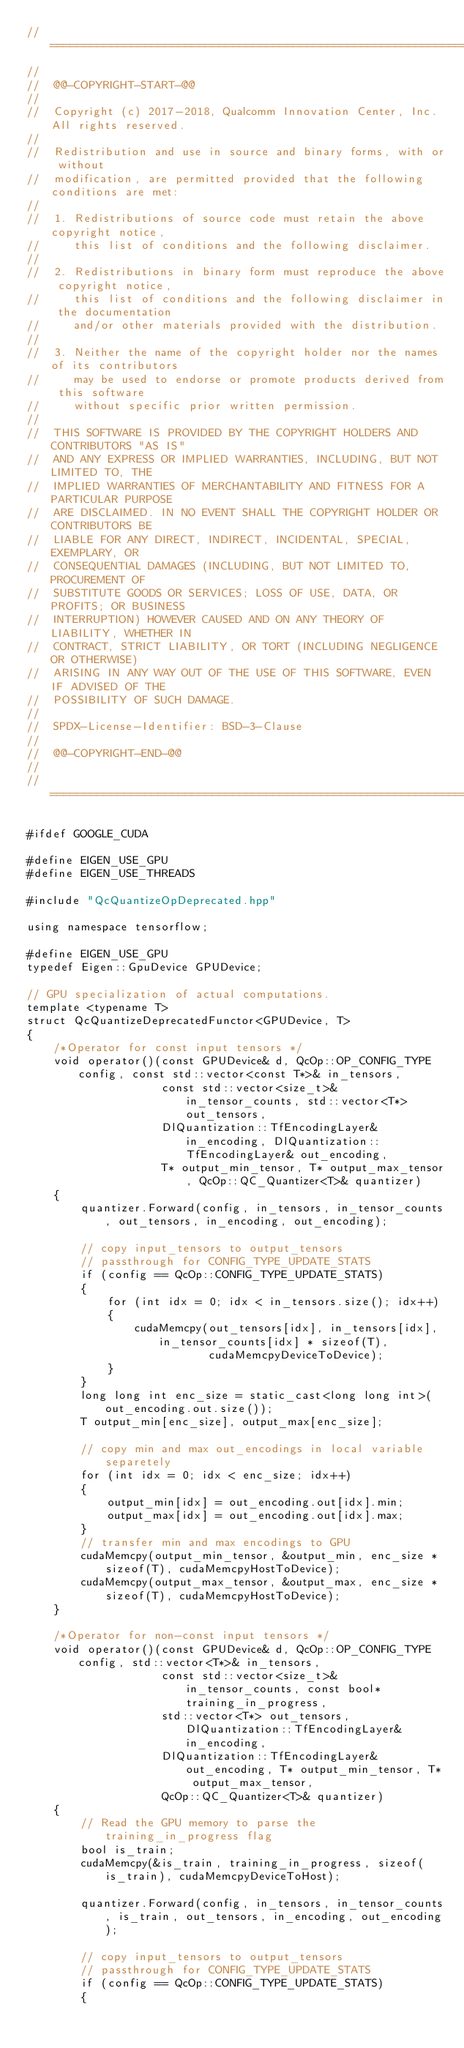Convert code to text. <code><loc_0><loc_0><loc_500><loc_500><_Cuda_>//==============================================================================
//
//  @@-COPYRIGHT-START-@@
//
//  Copyright (c) 2017-2018, Qualcomm Innovation Center, Inc. All rights reserved.
//
//  Redistribution and use in source and binary forms, with or without
//  modification, are permitted provided that the following conditions are met:
//
//  1. Redistributions of source code must retain the above copyright notice,
//     this list of conditions and the following disclaimer.
//
//  2. Redistributions in binary form must reproduce the above copyright notice,
//     this list of conditions and the following disclaimer in the documentation
//     and/or other materials provided with the distribution.
//
//  3. Neither the name of the copyright holder nor the names of its contributors
//     may be used to endorse or promote products derived from this software
//     without specific prior written permission.
//
//  THIS SOFTWARE IS PROVIDED BY THE COPYRIGHT HOLDERS AND CONTRIBUTORS "AS IS"
//  AND ANY EXPRESS OR IMPLIED WARRANTIES, INCLUDING, BUT NOT LIMITED TO, THE
//  IMPLIED WARRANTIES OF MERCHANTABILITY AND FITNESS FOR A PARTICULAR PURPOSE
//  ARE DISCLAIMED. IN NO EVENT SHALL THE COPYRIGHT HOLDER OR CONTRIBUTORS BE
//  LIABLE FOR ANY DIRECT, INDIRECT, INCIDENTAL, SPECIAL, EXEMPLARY, OR
//  CONSEQUENTIAL DAMAGES (INCLUDING, BUT NOT LIMITED TO, PROCUREMENT OF
//  SUBSTITUTE GOODS OR SERVICES; LOSS OF USE, DATA, OR PROFITS; OR BUSINESS
//  INTERRUPTION) HOWEVER CAUSED AND ON ANY THEORY OF LIABILITY, WHETHER IN
//  CONTRACT, STRICT LIABILITY, OR TORT (INCLUDING NEGLIGENCE OR OTHERWISE)
//  ARISING IN ANY WAY OUT OF THE USE OF THIS SOFTWARE, EVEN IF ADVISED OF THE
//  POSSIBILITY OF SUCH DAMAGE.
//
//  SPDX-License-Identifier: BSD-3-Clause
//
//  @@-COPYRIGHT-END-@@
//
//==============================================================================

#ifdef GOOGLE_CUDA

#define EIGEN_USE_GPU
#define EIGEN_USE_THREADS

#include "QcQuantizeOpDeprecated.hpp"

using namespace tensorflow;

#define EIGEN_USE_GPU
typedef Eigen::GpuDevice GPUDevice;

// GPU specialization of actual computations.
template <typename T>
struct QcQuantizeDeprecatedFunctor<GPUDevice, T>
{
    /*Operator for const input tensors */
    void operator()(const GPUDevice& d, QcOp::OP_CONFIG_TYPE config, const std::vector<const T*>& in_tensors,
                    const std::vector<size_t>& in_tensor_counts, std::vector<T*> out_tensors,
                    DlQuantization::TfEncodingLayer& in_encoding, DlQuantization::TfEncodingLayer& out_encoding,
                    T* output_min_tensor, T* output_max_tensor, QcOp::QC_Quantizer<T>& quantizer)
    {
        quantizer.Forward(config, in_tensors, in_tensor_counts, out_tensors, in_encoding, out_encoding);

        // copy input_tensors to output_tensors
        // passthrough for CONFIG_TYPE_UPDATE_STATS
        if (config == QcOp::CONFIG_TYPE_UPDATE_STATS)
        {
            for (int idx = 0; idx < in_tensors.size(); idx++)
            {
                cudaMemcpy(out_tensors[idx], in_tensors[idx], in_tensor_counts[idx] * sizeof(T),
                           cudaMemcpyDeviceToDevice);
            }
        }
        long long int enc_size = static_cast<long long int>(out_encoding.out.size());
        T output_min[enc_size], output_max[enc_size];

        // copy min and max out_encodings in local variable separetely
        for (int idx = 0; idx < enc_size; idx++)
        {
            output_min[idx] = out_encoding.out[idx].min;
            output_max[idx] = out_encoding.out[idx].max;
        }
        // transfer min and max encodings to GPU
        cudaMemcpy(output_min_tensor, &output_min, enc_size * sizeof(T), cudaMemcpyHostToDevice);
        cudaMemcpy(output_max_tensor, &output_max, enc_size * sizeof(T), cudaMemcpyHostToDevice);
    }

    /*Operator for non-const input tensors */
    void operator()(const GPUDevice& d, QcOp::OP_CONFIG_TYPE config, std::vector<T*>& in_tensors,
                    const std::vector<size_t>& in_tensor_counts, const bool* training_in_progress,
                    std::vector<T*> out_tensors, DlQuantization::TfEncodingLayer& in_encoding,
                    DlQuantization::TfEncodingLayer& out_encoding, T* output_min_tensor, T* output_max_tensor,
                    QcOp::QC_Quantizer<T>& quantizer)
    {
        // Read the GPU memory to parse the training_in_progress flag
        bool is_train;
        cudaMemcpy(&is_train, training_in_progress, sizeof(is_train), cudaMemcpyDeviceToHost);

        quantizer.Forward(config, in_tensors, in_tensor_counts, is_train, out_tensors, in_encoding, out_encoding);

        // copy input_tensors to output_tensors
        // passthrough for CONFIG_TYPE_UPDATE_STATS
        if (config == QcOp::CONFIG_TYPE_UPDATE_STATS)
        {</code> 